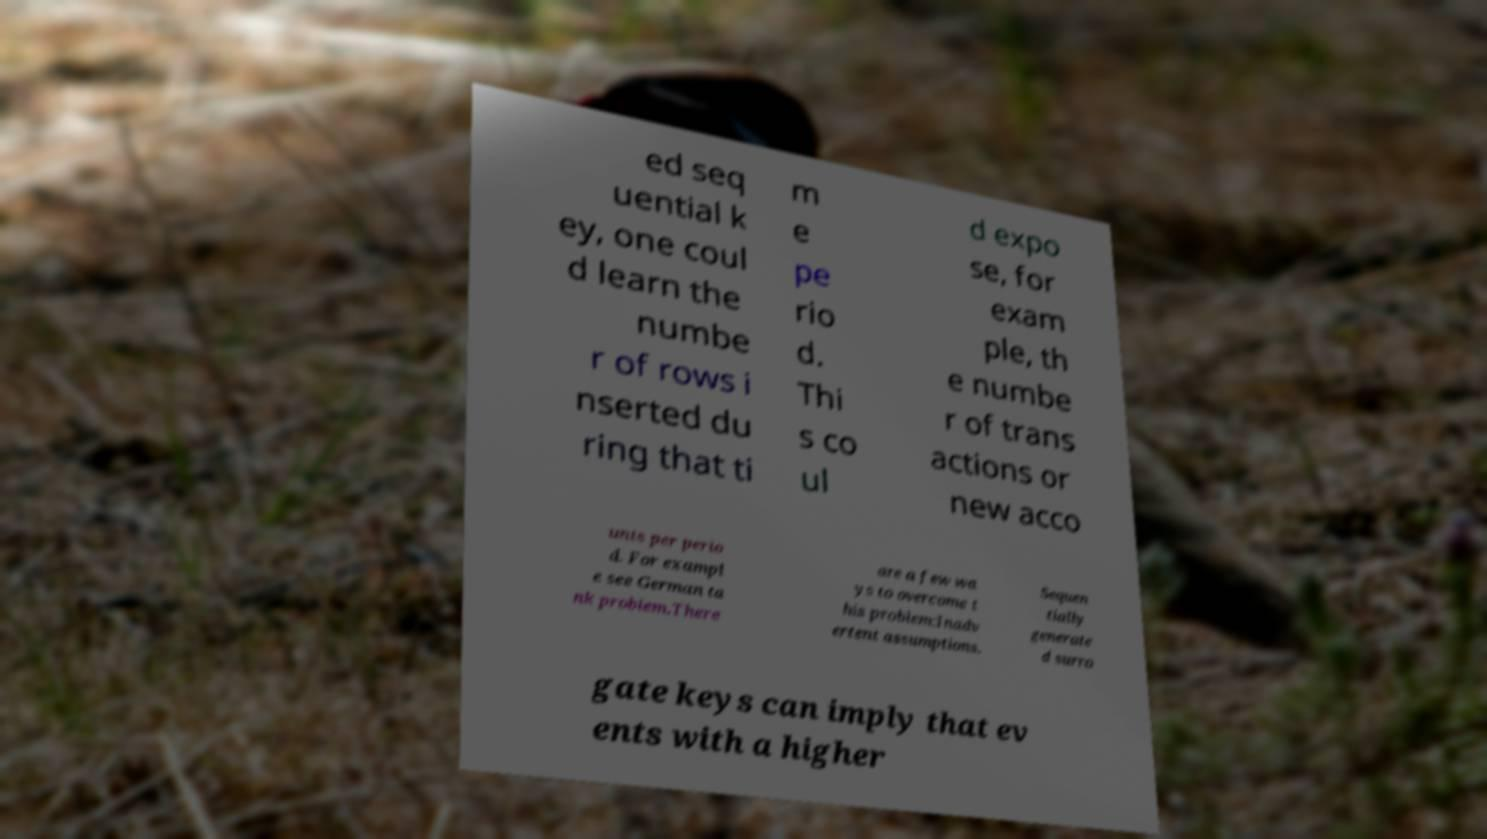There's text embedded in this image that I need extracted. Can you transcribe it verbatim? ed seq uential k ey, one coul d learn the numbe r of rows i nserted du ring that ti m e pe rio d. Thi s co ul d expo se, for exam ple, th e numbe r of trans actions or new acco unts per perio d. For exampl e see German ta nk problem.There are a few wa ys to overcome t his problem:Inadv ertent assumptions. Sequen tially generate d surro gate keys can imply that ev ents with a higher 